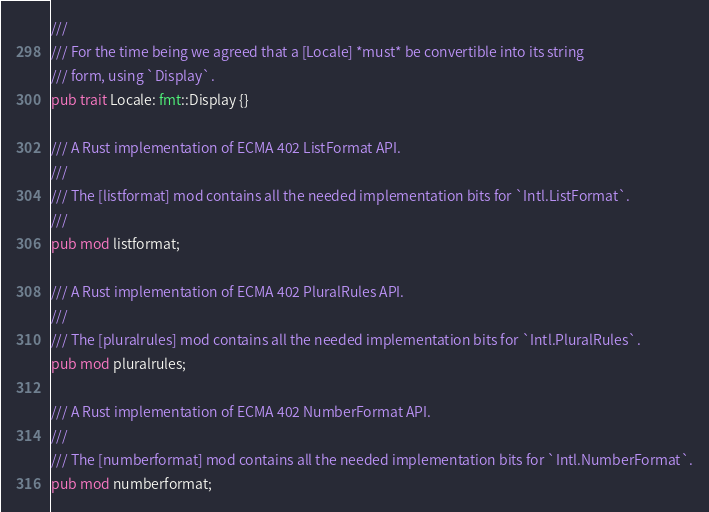<code> <loc_0><loc_0><loc_500><loc_500><_Rust_>///
/// For the time being we agreed that a [Locale] *must* be convertible into its string
/// form, using `Display`.
pub trait Locale: fmt::Display {}

/// A Rust implementation of ECMA 402 ListFormat API.
///
/// The [listformat] mod contains all the needed implementation bits for `Intl.ListFormat`.
///
pub mod listformat;

/// A Rust implementation of ECMA 402 PluralRules API.
///
/// The [pluralrules] mod contains all the needed implementation bits for `Intl.PluralRules`.
pub mod pluralrules;

/// A Rust implementation of ECMA 402 NumberFormat API.
///
/// The [numberformat] mod contains all the needed implementation bits for `Intl.NumberFormat`.
pub mod numberformat;
</code> 